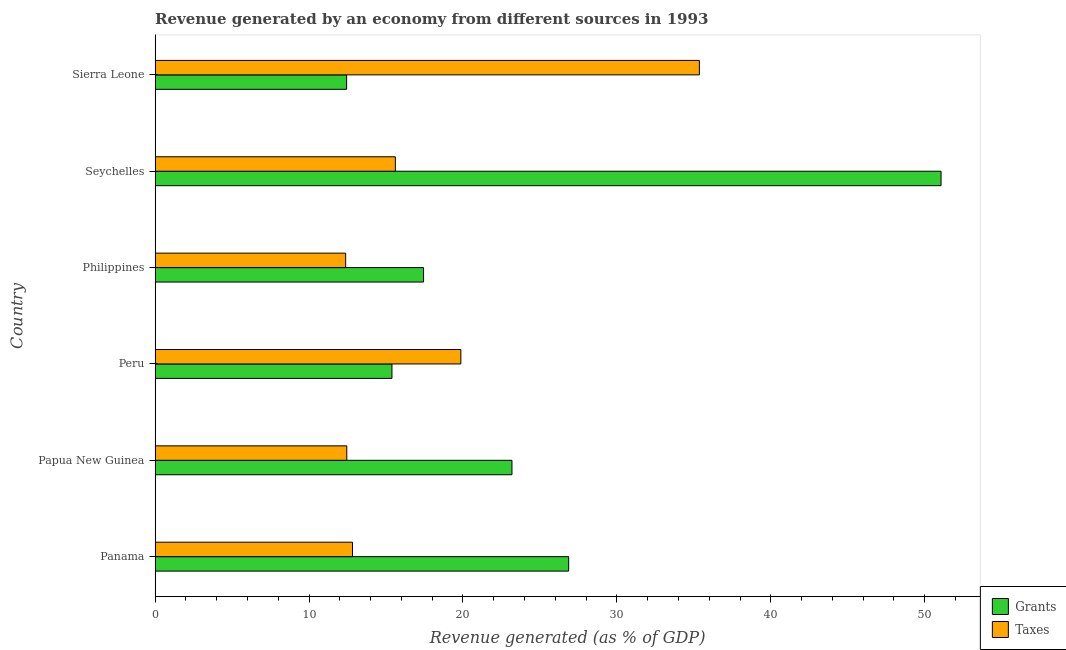Are the number of bars per tick equal to the number of legend labels?
Offer a terse response. Yes. How many bars are there on the 4th tick from the top?
Your answer should be very brief. 2. How many bars are there on the 4th tick from the bottom?
Offer a very short reply. 2. What is the label of the 3rd group of bars from the top?
Offer a very short reply. Philippines. In how many cases, is the number of bars for a given country not equal to the number of legend labels?
Make the answer very short. 0. What is the revenue generated by grants in Seychelles?
Make the answer very short. 51.06. Across all countries, what is the maximum revenue generated by grants?
Offer a terse response. 51.06. Across all countries, what is the minimum revenue generated by taxes?
Provide a succinct answer. 12.38. In which country was the revenue generated by grants maximum?
Your response must be concise. Seychelles. What is the total revenue generated by taxes in the graph?
Provide a short and direct response. 108.5. What is the difference between the revenue generated by grants in Panama and that in Peru?
Provide a short and direct response. 11.48. What is the difference between the revenue generated by taxes in Philippines and the revenue generated by grants in Papua New Guinea?
Keep it short and to the point. -10.8. What is the average revenue generated by taxes per country?
Your answer should be compact. 18.08. What is the difference between the revenue generated by grants and revenue generated by taxes in Seychelles?
Offer a terse response. 35.45. What is the ratio of the revenue generated by taxes in Peru to that in Sierra Leone?
Give a very brief answer. 0.56. What is the difference between the highest and the second highest revenue generated by grants?
Give a very brief answer. 24.19. What is the difference between the highest and the lowest revenue generated by taxes?
Offer a very short reply. 22.98. In how many countries, is the revenue generated by grants greater than the average revenue generated by grants taken over all countries?
Keep it short and to the point. 2. Is the sum of the revenue generated by grants in Papua New Guinea and Seychelles greater than the maximum revenue generated by taxes across all countries?
Your answer should be compact. Yes. What does the 2nd bar from the top in Peru represents?
Keep it short and to the point. Grants. What does the 2nd bar from the bottom in Philippines represents?
Keep it short and to the point. Taxes. How many bars are there?
Your answer should be very brief. 12. Are all the bars in the graph horizontal?
Give a very brief answer. Yes. Does the graph contain any zero values?
Keep it short and to the point. No. Where does the legend appear in the graph?
Ensure brevity in your answer.  Bottom right. How many legend labels are there?
Give a very brief answer. 2. What is the title of the graph?
Provide a succinct answer. Revenue generated by an economy from different sources in 1993. Does "State government" appear as one of the legend labels in the graph?
Your answer should be very brief. No. What is the label or title of the X-axis?
Give a very brief answer. Revenue generated (as % of GDP). What is the label or title of the Y-axis?
Ensure brevity in your answer.  Country. What is the Revenue generated (as % of GDP) of Grants in Panama?
Make the answer very short. 26.87. What is the Revenue generated (as % of GDP) in Taxes in Panama?
Offer a very short reply. 12.83. What is the Revenue generated (as % of GDP) in Grants in Papua New Guinea?
Your answer should be compact. 23.19. What is the Revenue generated (as % of GDP) in Taxes in Papua New Guinea?
Make the answer very short. 12.45. What is the Revenue generated (as % of GDP) of Grants in Peru?
Your answer should be very brief. 15.39. What is the Revenue generated (as % of GDP) of Taxes in Peru?
Provide a short and direct response. 19.86. What is the Revenue generated (as % of GDP) of Grants in Philippines?
Make the answer very short. 17.44. What is the Revenue generated (as % of GDP) of Taxes in Philippines?
Offer a very short reply. 12.38. What is the Revenue generated (as % of GDP) in Grants in Seychelles?
Give a very brief answer. 51.06. What is the Revenue generated (as % of GDP) of Taxes in Seychelles?
Provide a succinct answer. 15.61. What is the Revenue generated (as % of GDP) of Grants in Sierra Leone?
Offer a terse response. 12.44. What is the Revenue generated (as % of GDP) in Taxes in Sierra Leone?
Offer a terse response. 35.36. Across all countries, what is the maximum Revenue generated (as % of GDP) of Grants?
Provide a short and direct response. 51.06. Across all countries, what is the maximum Revenue generated (as % of GDP) in Taxes?
Your answer should be very brief. 35.36. Across all countries, what is the minimum Revenue generated (as % of GDP) of Grants?
Your answer should be compact. 12.44. Across all countries, what is the minimum Revenue generated (as % of GDP) of Taxes?
Your answer should be compact. 12.38. What is the total Revenue generated (as % of GDP) of Grants in the graph?
Make the answer very short. 146.39. What is the total Revenue generated (as % of GDP) of Taxes in the graph?
Your answer should be very brief. 108.5. What is the difference between the Revenue generated (as % of GDP) in Grants in Panama and that in Papua New Guinea?
Offer a terse response. 3.68. What is the difference between the Revenue generated (as % of GDP) of Taxes in Panama and that in Papua New Guinea?
Ensure brevity in your answer.  0.37. What is the difference between the Revenue generated (as % of GDP) of Grants in Panama and that in Peru?
Offer a terse response. 11.48. What is the difference between the Revenue generated (as % of GDP) of Taxes in Panama and that in Peru?
Your response must be concise. -7.04. What is the difference between the Revenue generated (as % of GDP) in Grants in Panama and that in Philippines?
Provide a succinct answer. 9.43. What is the difference between the Revenue generated (as % of GDP) of Taxes in Panama and that in Philippines?
Give a very brief answer. 0.45. What is the difference between the Revenue generated (as % of GDP) of Grants in Panama and that in Seychelles?
Give a very brief answer. -24.19. What is the difference between the Revenue generated (as % of GDP) in Taxes in Panama and that in Seychelles?
Offer a terse response. -2.78. What is the difference between the Revenue generated (as % of GDP) of Grants in Panama and that in Sierra Leone?
Your response must be concise. 14.42. What is the difference between the Revenue generated (as % of GDP) in Taxes in Panama and that in Sierra Leone?
Ensure brevity in your answer.  -22.53. What is the difference between the Revenue generated (as % of GDP) of Grants in Papua New Guinea and that in Peru?
Keep it short and to the point. 7.8. What is the difference between the Revenue generated (as % of GDP) of Taxes in Papua New Guinea and that in Peru?
Ensure brevity in your answer.  -7.41. What is the difference between the Revenue generated (as % of GDP) in Grants in Papua New Guinea and that in Philippines?
Offer a terse response. 5.74. What is the difference between the Revenue generated (as % of GDP) in Taxes in Papua New Guinea and that in Philippines?
Ensure brevity in your answer.  0.07. What is the difference between the Revenue generated (as % of GDP) of Grants in Papua New Guinea and that in Seychelles?
Make the answer very short. -27.87. What is the difference between the Revenue generated (as % of GDP) of Taxes in Papua New Guinea and that in Seychelles?
Make the answer very short. -3.16. What is the difference between the Revenue generated (as % of GDP) of Grants in Papua New Guinea and that in Sierra Leone?
Offer a terse response. 10.74. What is the difference between the Revenue generated (as % of GDP) in Taxes in Papua New Guinea and that in Sierra Leone?
Offer a very short reply. -22.91. What is the difference between the Revenue generated (as % of GDP) in Grants in Peru and that in Philippines?
Keep it short and to the point. -2.05. What is the difference between the Revenue generated (as % of GDP) in Taxes in Peru and that in Philippines?
Your answer should be compact. 7.48. What is the difference between the Revenue generated (as % of GDP) of Grants in Peru and that in Seychelles?
Offer a terse response. -35.67. What is the difference between the Revenue generated (as % of GDP) of Taxes in Peru and that in Seychelles?
Give a very brief answer. 4.25. What is the difference between the Revenue generated (as % of GDP) of Grants in Peru and that in Sierra Leone?
Offer a very short reply. 2.94. What is the difference between the Revenue generated (as % of GDP) in Taxes in Peru and that in Sierra Leone?
Provide a succinct answer. -15.5. What is the difference between the Revenue generated (as % of GDP) of Grants in Philippines and that in Seychelles?
Provide a short and direct response. -33.62. What is the difference between the Revenue generated (as % of GDP) in Taxes in Philippines and that in Seychelles?
Offer a terse response. -3.23. What is the difference between the Revenue generated (as % of GDP) in Grants in Philippines and that in Sierra Leone?
Make the answer very short. 5. What is the difference between the Revenue generated (as % of GDP) in Taxes in Philippines and that in Sierra Leone?
Make the answer very short. -22.98. What is the difference between the Revenue generated (as % of GDP) in Grants in Seychelles and that in Sierra Leone?
Provide a short and direct response. 38.61. What is the difference between the Revenue generated (as % of GDP) of Taxes in Seychelles and that in Sierra Leone?
Ensure brevity in your answer.  -19.75. What is the difference between the Revenue generated (as % of GDP) of Grants in Panama and the Revenue generated (as % of GDP) of Taxes in Papua New Guinea?
Make the answer very short. 14.41. What is the difference between the Revenue generated (as % of GDP) in Grants in Panama and the Revenue generated (as % of GDP) in Taxes in Peru?
Give a very brief answer. 7. What is the difference between the Revenue generated (as % of GDP) in Grants in Panama and the Revenue generated (as % of GDP) in Taxes in Philippines?
Your answer should be very brief. 14.49. What is the difference between the Revenue generated (as % of GDP) of Grants in Panama and the Revenue generated (as % of GDP) of Taxes in Seychelles?
Offer a very short reply. 11.26. What is the difference between the Revenue generated (as % of GDP) of Grants in Panama and the Revenue generated (as % of GDP) of Taxes in Sierra Leone?
Give a very brief answer. -8.49. What is the difference between the Revenue generated (as % of GDP) in Grants in Papua New Guinea and the Revenue generated (as % of GDP) in Taxes in Peru?
Keep it short and to the point. 3.32. What is the difference between the Revenue generated (as % of GDP) in Grants in Papua New Guinea and the Revenue generated (as % of GDP) in Taxes in Philippines?
Your response must be concise. 10.8. What is the difference between the Revenue generated (as % of GDP) of Grants in Papua New Guinea and the Revenue generated (as % of GDP) of Taxes in Seychelles?
Give a very brief answer. 7.57. What is the difference between the Revenue generated (as % of GDP) in Grants in Papua New Guinea and the Revenue generated (as % of GDP) in Taxes in Sierra Leone?
Provide a succinct answer. -12.17. What is the difference between the Revenue generated (as % of GDP) in Grants in Peru and the Revenue generated (as % of GDP) in Taxes in Philippines?
Offer a very short reply. 3.01. What is the difference between the Revenue generated (as % of GDP) of Grants in Peru and the Revenue generated (as % of GDP) of Taxes in Seychelles?
Your answer should be very brief. -0.22. What is the difference between the Revenue generated (as % of GDP) in Grants in Peru and the Revenue generated (as % of GDP) in Taxes in Sierra Leone?
Offer a very short reply. -19.97. What is the difference between the Revenue generated (as % of GDP) in Grants in Philippines and the Revenue generated (as % of GDP) in Taxes in Seychelles?
Give a very brief answer. 1.83. What is the difference between the Revenue generated (as % of GDP) in Grants in Philippines and the Revenue generated (as % of GDP) in Taxes in Sierra Leone?
Offer a terse response. -17.92. What is the difference between the Revenue generated (as % of GDP) in Grants in Seychelles and the Revenue generated (as % of GDP) in Taxes in Sierra Leone?
Your answer should be compact. 15.7. What is the average Revenue generated (as % of GDP) in Grants per country?
Provide a short and direct response. 24.4. What is the average Revenue generated (as % of GDP) of Taxes per country?
Make the answer very short. 18.08. What is the difference between the Revenue generated (as % of GDP) of Grants and Revenue generated (as % of GDP) of Taxes in Panama?
Make the answer very short. 14.04. What is the difference between the Revenue generated (as % of GDP) in Grants and Revenue generated (as % of GDP) in Taxes in Papua New Guinea?
Give a very brief answer. 10.73. What is the difference between the Revenue generated (as % of GDP) of Grants and Revenue generated (as % of GDP) of Taxes in Peru?
Your response must be concise. -4.48. What is the difference between the Revenue generated (as % of GDP) of Grants and Revenue generated (as % of GDP) of Taxes in Philippines?
Give a very brief answer. 5.06. What is the difference between the Revenue generated (as % of GDP) in Grants and Revenue generated (as % of GDP) in Taxes in Seychelles?
Give a very brief answer. 35.45. What is the difference between the Revenue generated (as % of GDP) in Grants and Revenue generated (as % of GDP) in Taxes in Sierra Leone?
Your answer should be very brief. -22.92. What is the ratio of the Revenue generated (as % of GDP) of Grants in Panama to that in Papua New Guinea?
Ensure brevity in your answer.  1.16. What is the ratio of the Revenue generated (as % of GDP) of Taxes in Panama to that in Papua New Guinea?
Offer a very short reply. 1.03. What is the ratio of the Revenue generated (as % of GDP) of Grants in Panama to that in Peru?
Your answer should be compact. 1.75. What is the ratio of the Revenue generated (as % of GDP) of Taxes in Panama to that in Peru?
Provide a short and direct response. 0.65. What is the ratio of the Revenue generated (as % of GDP) in Grants in Panama to that in Philippines?
Provide a short and direct response. 1.54. What is the ratio of the Revenue generated (as % of GDP) in Taxes in Panama to that in Philippines?
Your answer should be very brief. 1.04. What is the ratio of the Revenue generated (as % of GDP) of Grants in Panama to that in Seychelles?
Offer a very short reply. 0.53. What is the ratio of the Revenue generated (as % of GDP) of Taxes in Panama to that in Seychelles?
Provide a short and direct response. 0.82. What is the ratio of the Revenue generated (as % of GDP) in Grants in Panama to that in Sierra Leone?
Provide a succinct answer. 2.16. What is the ratio of the Revenue generated (as % of GDP) of Taxes in Panama to that in Sierra Leone?
Your answer should be compact. 0.36. What is the ratio of the Revenue generated (as % of GDP) of Grants in Papua New Guinea to that in Peru?
Your response must be concise. 1.51. What is the ratio of the Revenue generated (as % of GDP) of Taxes in Papua New Guinea to that in Peru?
Make the answer very short. 0.63. What is the ratio of the Revenue generated (as % of GDP) in Grants in Papua New Guinea to that in Philippines?
Your answer should be very brief. 1.33. What is the ratio of the Revenue generated (as % of GDP) of Grants in Papua New Guinea to that in Seychelles?
Offer a terse response. 0.45. What is the ratio of the Revenue generated (as % of GDP) of Taxes in Papua New Guinea to that in Seychelles?
Keep it short and to the point. 0.8. What is the ratio of the Revenue generated (as % of GDP) in Grants in Papua New Guinea to that in Sierra Leone?
Keep it short and to the point. 1.86. What is the ratio of the Revenue generated (as % of GDP) in Taxes in Papua New Guinea to that in Sierra Leone?
Offer a very short reply. 0.35. What is the ratio of the Revenue generated (as % of GDP) of Grants in Peru to that in Philippines?
Offer a terse response. 0.88. What is the ratio of the Revenue generated (as % of GDP) of Taxes in Peru to that in Philippines?
Make the answer very short. 1.6. What is the ratio of the Revenue generated (as % of GDP) of Grants in Peru to that in Seychelles?
Offer a terse response. 0.3. What is the ratio of the Revenue generated (as % of GDP) of Taxes in Peru to that in Seychelles?
Your answer should be compact. 1.27. What is the ratio of the Revenue generated (as % of GDP) in Grants in Peru to that in Sierra Leone?
Make the answer very short. 1.24. What is the ratio of the Revenue generated (as % of GDP) of Taxes in Peru to that in Sierra Leone?
Offer a terse response. 0.56. What is the ratio of the Revenue generated (as % of GDP) of Grants in Philippines to that in Seychelles?
Offer a very short reply. 0.34. What is the ratio of the Revenue generated (as % of GDP) in Taxes in Philippines to that in Seychelles?
Offer a terse response. 0.79. What is the ratio of the Revenue generated (as % of GDP) in Grants in Philippines to that in Sierra Leone?
Offer a very short reply. 1.4. What is the ratio of the Revenue generated (as % of GDP) of Taxes in Philippines to that in Sierra Leone?
Offer a terse response. 0.35. What is the ratio of the Revenue generated (as % of GDP) of Grants in Seychelles to that in Sierra Leone?
Your answer should be compact. 4.1. What is the ratio of the Revenue generated (as % of GDP) in Taxes in Seychelles to that in Sierra Leone?
Your response must be concise. 0.44. What is the difference between the highest and the second highest Revenue generated (as % of GDP) of Grants?
Ensure brevity in your answer.  24.19. What is the difference between the highest and the second highest Revenue generated (as % of GDP) in Taxes?
Your answer should be compact. 15.5. What is the difference between the highest and the lowest Revenue generated (as % of GDP) of Grants?
Ensure brevity in your answer.  38.61. What is the difference between the highest and the lowest Revenue generated (as % of GDP) of Taxes?
Offer a very short reply. 22.98. 